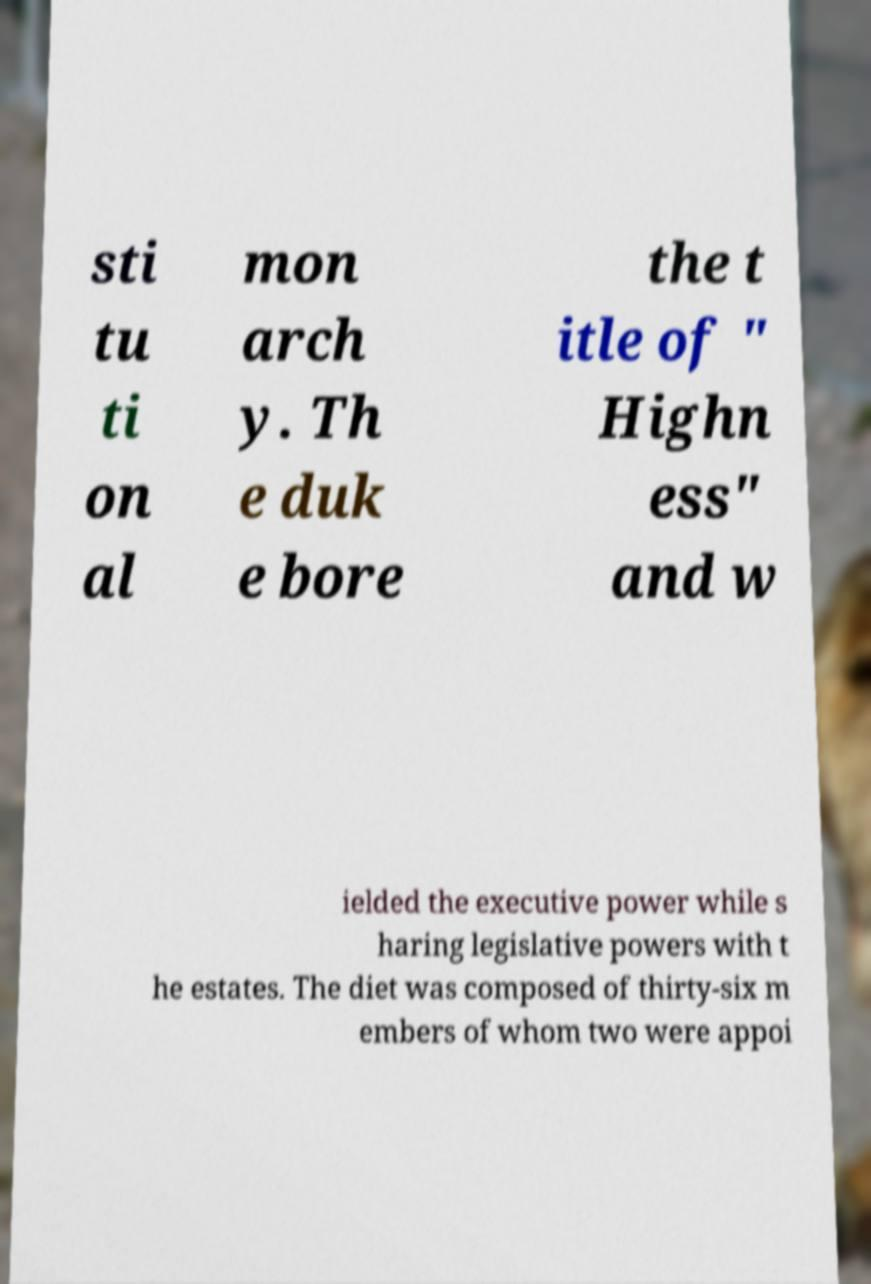For documentation purposes, I need the text within this image transcribed. Could you provide that? sti tu ti on al mon arch y. Th e duk e bore the t itle of " Highn ess" and w ielded the executive power while s haring legislative powers with t he estates. The diet was composed of thirty-six m embers of whom two were appoi 